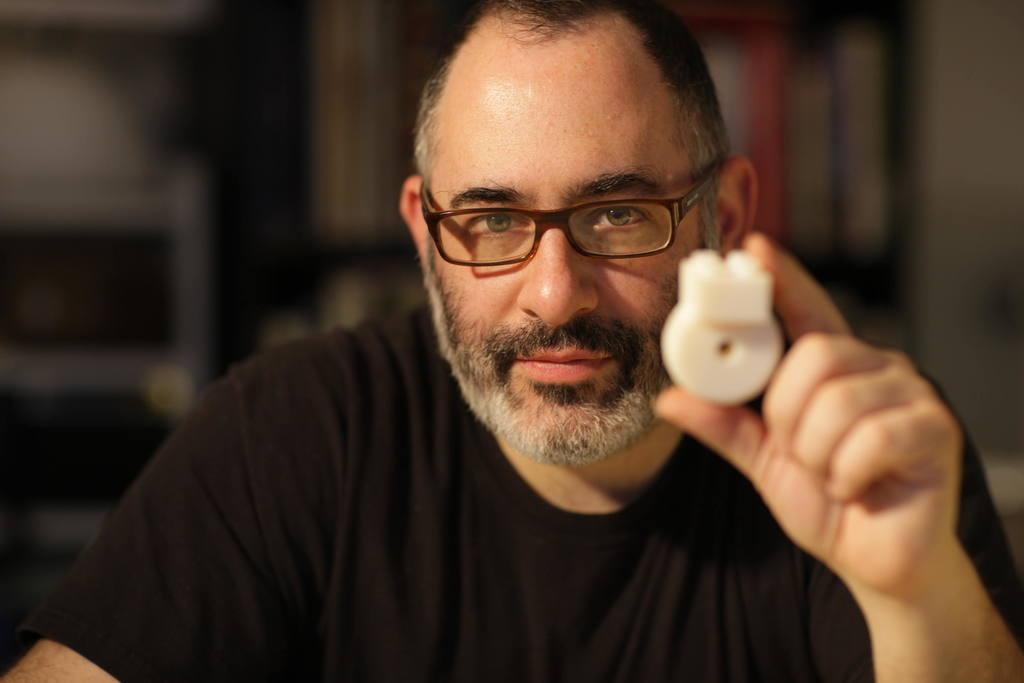What is the main subject of the image? There is a man in the image. What is the man wearing in the image? The man is wearing a black t-shirt. Can you describe the background of the image? The background of the image is blurred. What type of poison is the man holding in the image? There is no poison present in the image; the man is simply wearing a black t-shirt. What is the man using the rod for in the image? There is no rod present in the image, and the man is not shown using any object. 